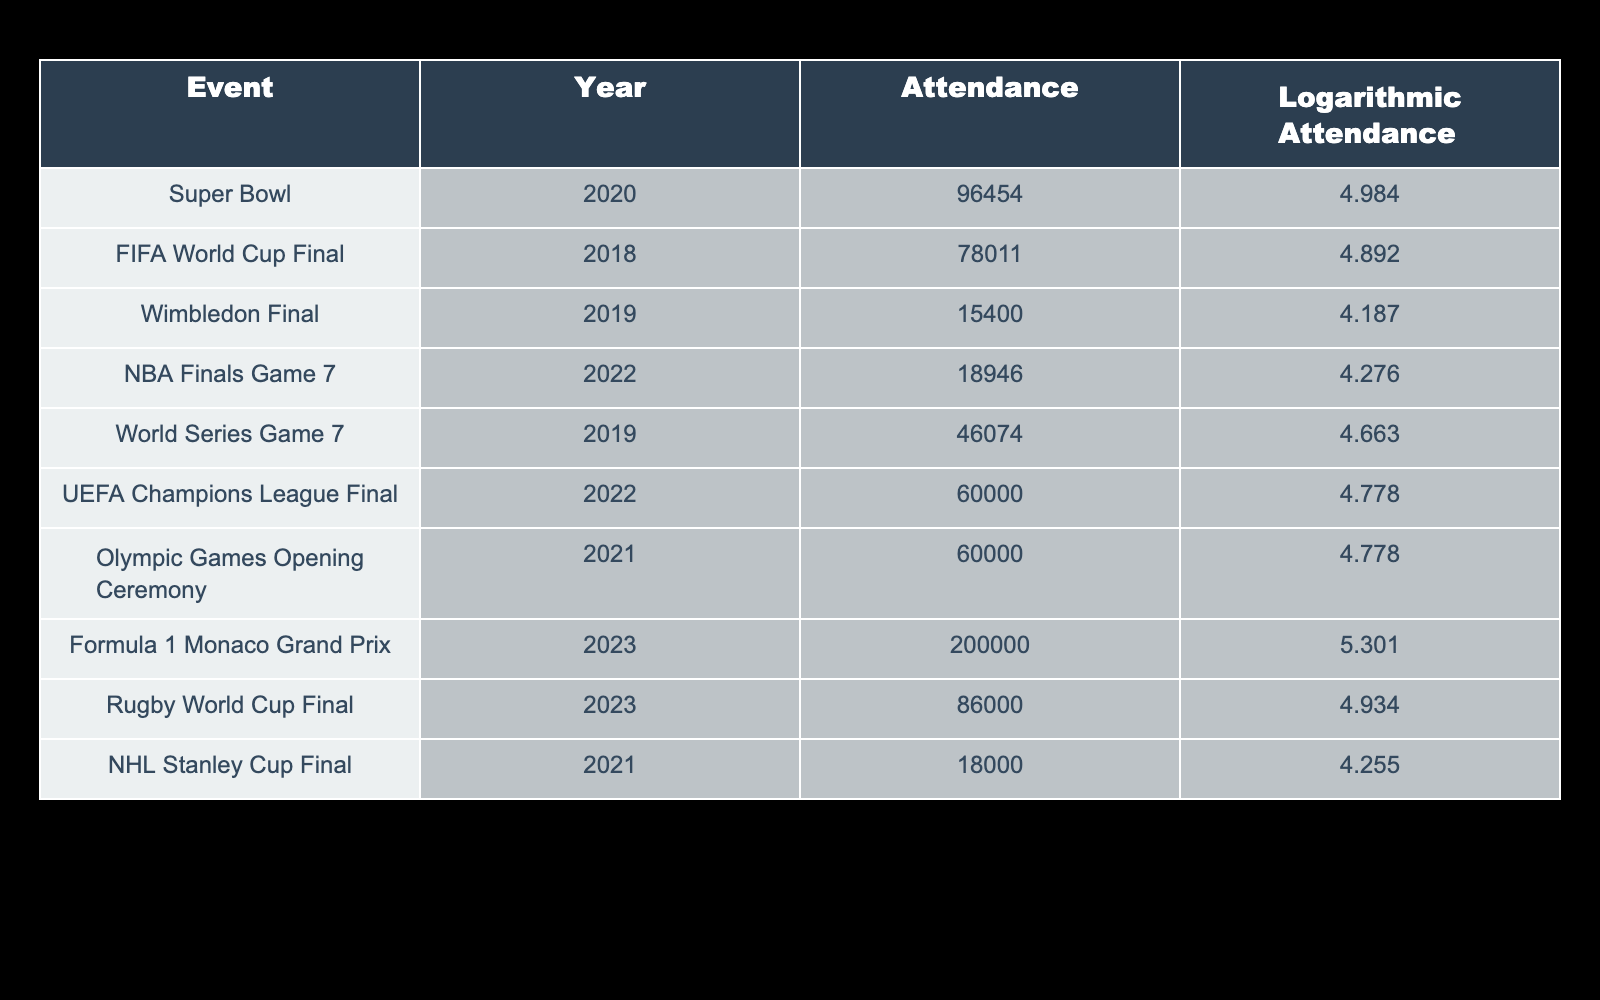What is the highest attendance figure in the table? The attendance figures from the table are: 96454 (Super Bowl), 78011 (FIFA World Cup Final), 15400 (Wimbledon Final), 18946 (NBA Finals Game 7), 46074 (World Series Game 7), 60000 (UEFA Champions League Final), 60000 (Olympic Games Opening Ceremony), 200000 (Formula 1 Monaco Grand Prix), 86000 (Rugby World Cup Final), 18000 (NHL Stanley Cup Final). The highest attendance is 200000 from the Formula 1 Monaco Grand Prix.
Answer: 200000 Which event had the lowest logarithmic attendance value? The logarithmic attendance values from the table are: 4.984 (Super Bowl), 4.892 (FIFA World Cup Final), 4.187 (Wimbledon Final), 4.276 (NBA Finals Game 7), 4.663 (World Series Game 7), 4.778 (UEFA Champions League Final), 4.778 (Olympic Games Opening Ceremony), 5.301 (Formula 1 Monaco Grand Prix), 4.934 (Rugby World Cup Final), 4.255 (NHL Stanley Cup Final). The lowest value is 4.187 from the Wimbledon Final.
Answer: Wimbledon Final Is the attendance for the Rugby World Cup Final greater than that of the NBA Finals Game 7? The attendance figures are 86000 for the Rugby World Cup Final and 18946 for the NBA Finals Game 7. Since 86000 is greater than 18946, the statement is true.
Answer: Yes What is the average attendance of the events listed? The total attendance is calculated by summing all figures: 96454 + 78011 + 15400 + 18946 + 46074 + 60000 + 60000 + 200000 + 86000 + 18000 = 461985. There are 10 events, so the average attendance is 461985 / 10 = 46198.5.
Answer: 46198.5 How many events have an attendance figure over 60000? The events with attendance figures over 60000 are the Super Bowl (96454), FIFA World Cup Final (78011), Formula 1 Monaco Grand Prix (200000), Rugby World Cup Final (86000), and both UEFA Champions League Final and Olympic Games Opening Ceremony (60000). There are a total of 5 such events.
Answer: 5 